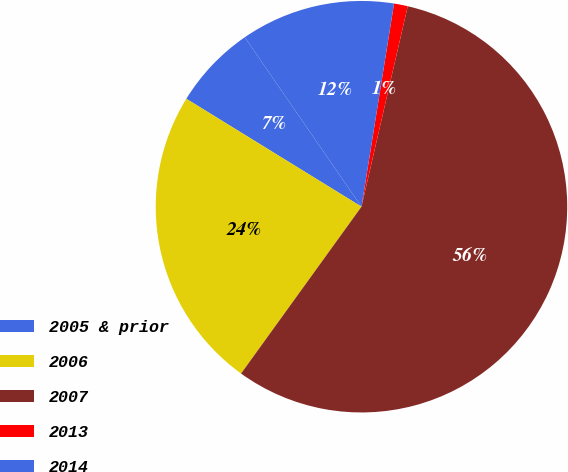Convert chart. <chart><loc_0><loc_0><loc_500><loc_500><pie_chart><fcel>2005 & prior<fcel>2006<fcel>2007<fcel>2013<fcel>2014<nl><fcel>6.61%<fcel>23.84%<fcel>56.34%<fcel>1.08%<fcel>12.13%<nl></chart> 